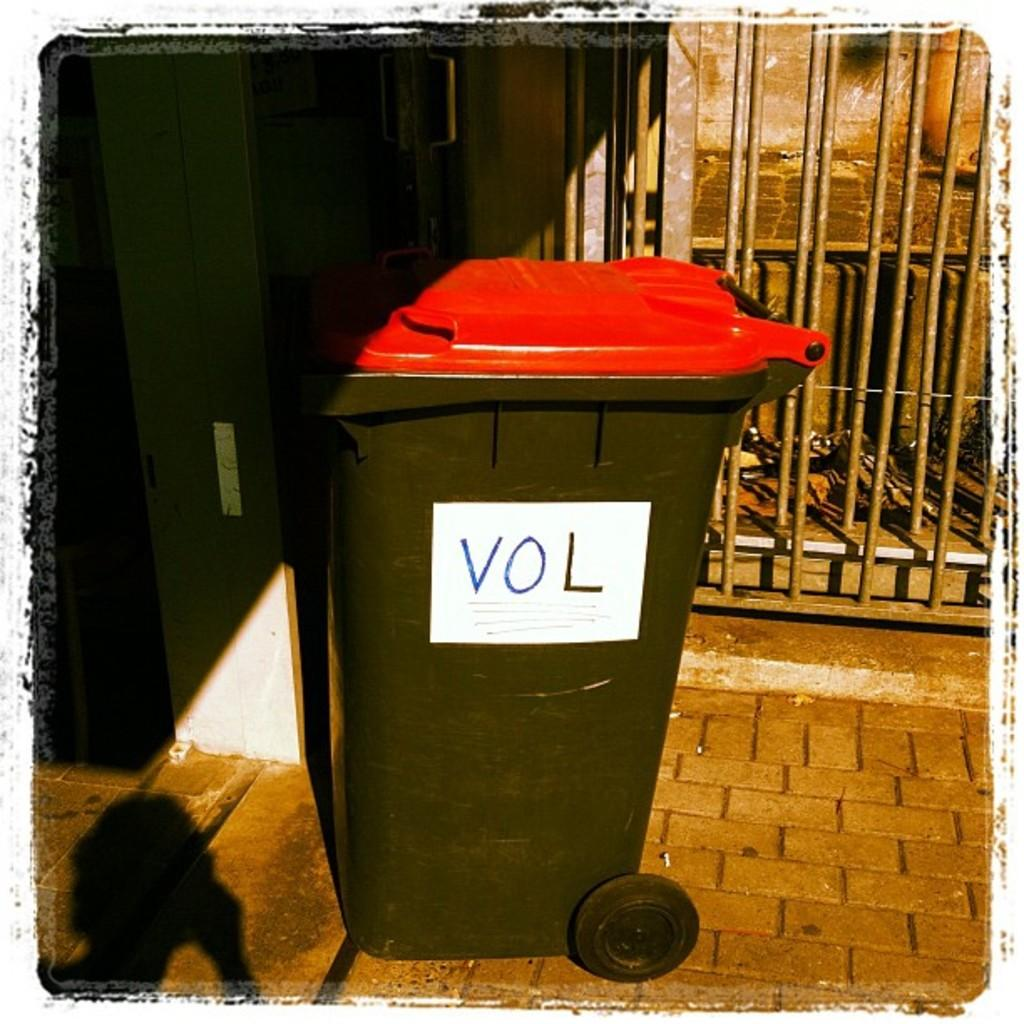<image>
Summarize the visual content of the image. A black garbage can with a red top has the word Vol on it. 